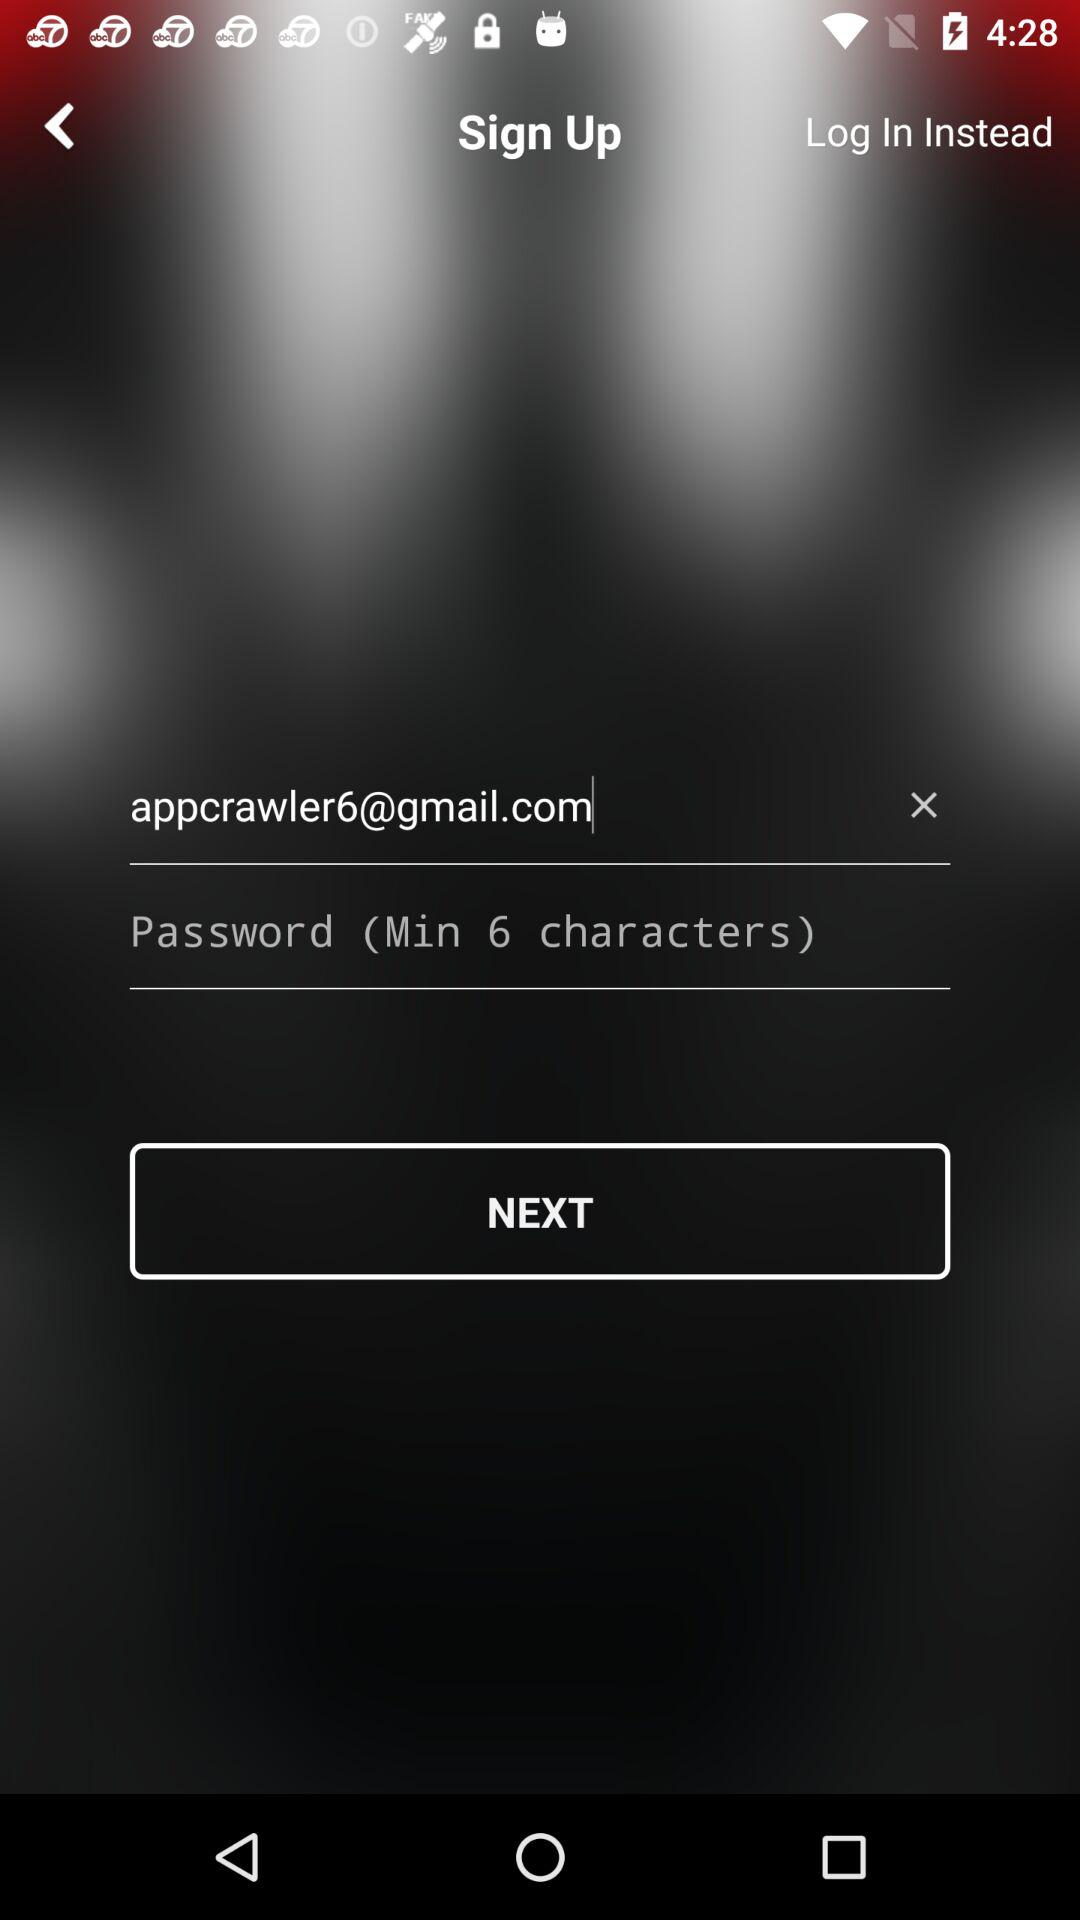How many text fields are there on this screen?
Answer the question using a single word or phrase. 2 